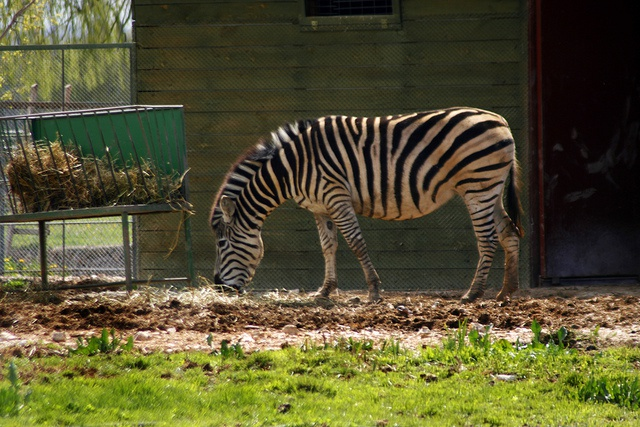Describe the objects in this image and their specific colors. I can see a zebra in olive, black, gray, and maroon tones in this image. 